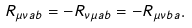Convert formula to latex. <formula><loc_0><loc_0><loc_500><loc_500>R _ { \mu \nu a b } = - R _ { \nu \mu a b } = - R _ { \mu \nu b a } .</formula> 